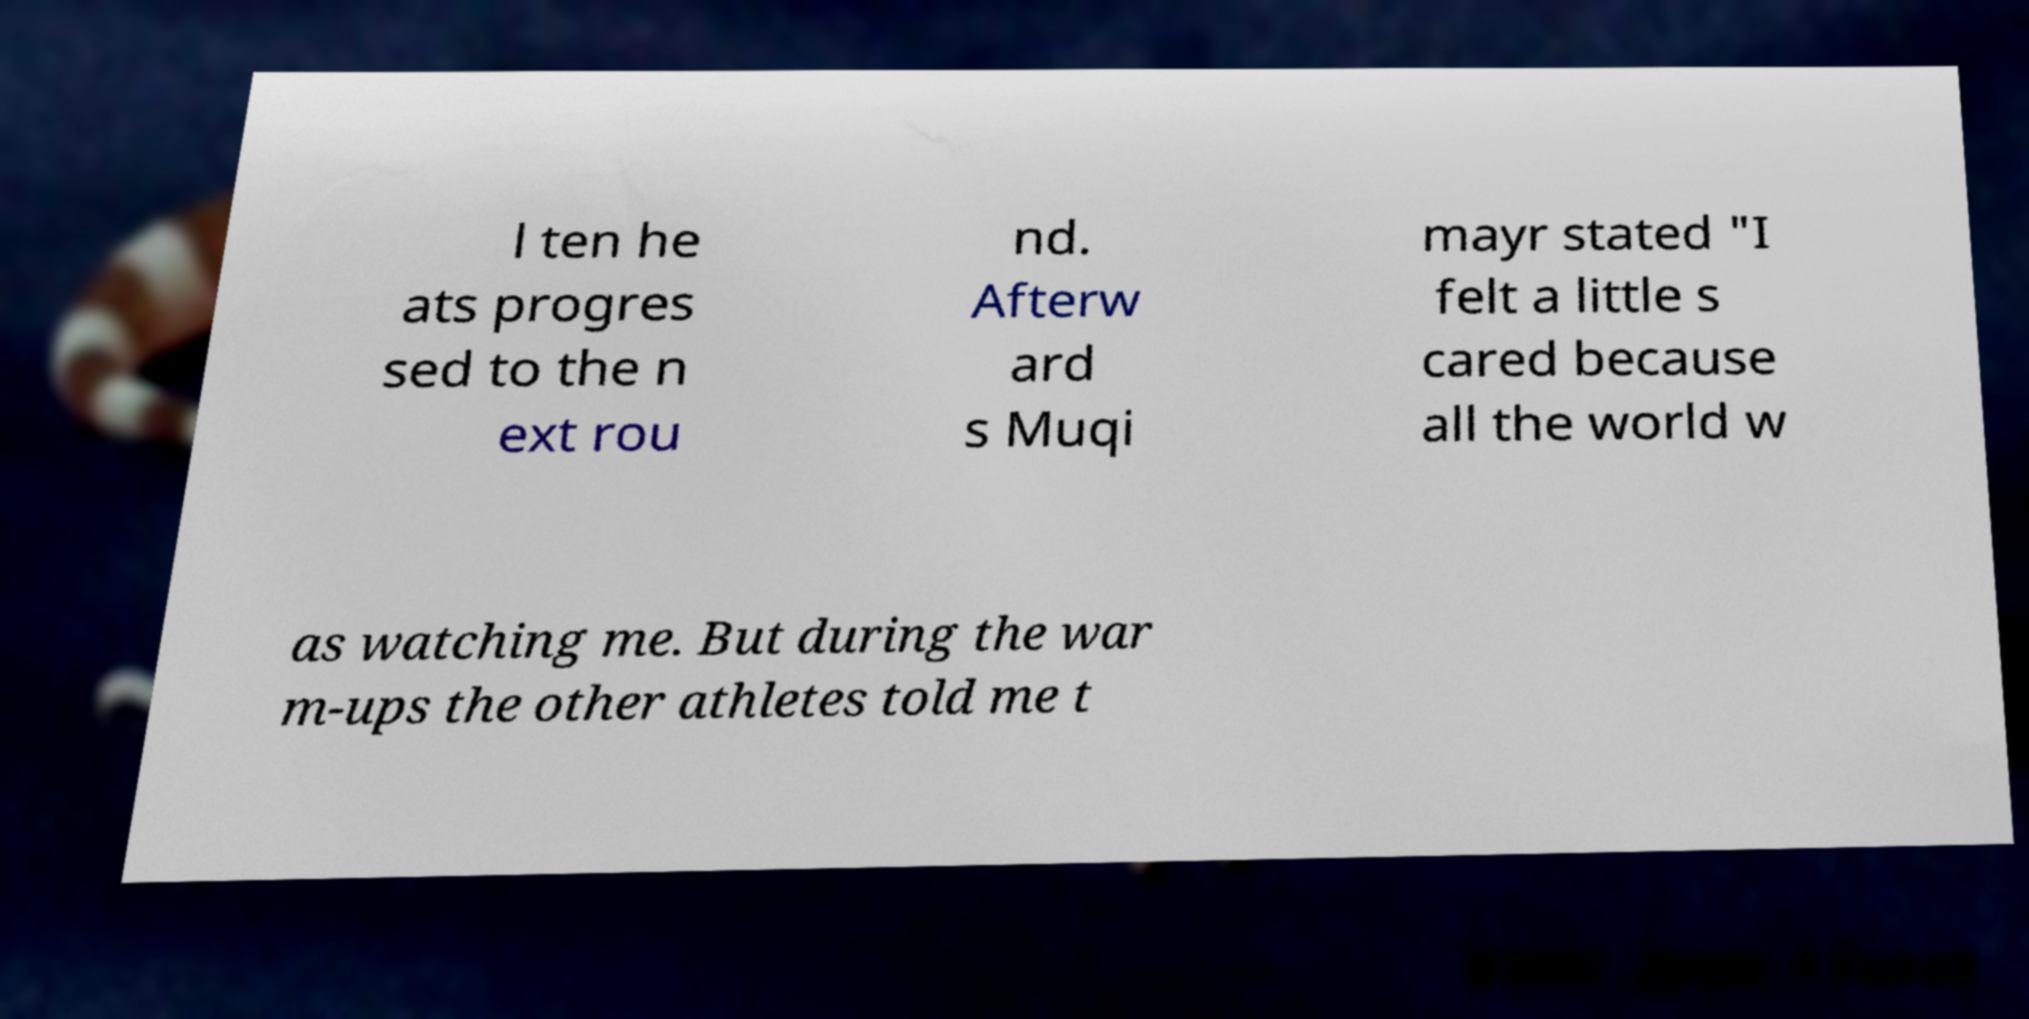Can you read and provide the text displayed in the image?This photo seems to have some interesting text. Can you extract and type it out for me? l ten he ats progres sed to the n ext rou nd. Afterw ard s Muqi mayr stated "I felt a little s cared because all the world w as watching me. But during the war m-ups the other athletes told me t 